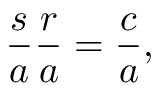<formula> <loc_0><loc_0><loc_500><loc_500>{ \frac { s } { a } } { \frac { r } { a } } = { \frac { c } { a } } ,</formula> 